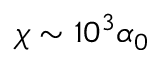Convert formula to latex. <formula><loc_0><loc_0><loc_500><loc_500>\chi \sim 1 0 ^ { 3 } \alpha _ { 0 }</formula> 